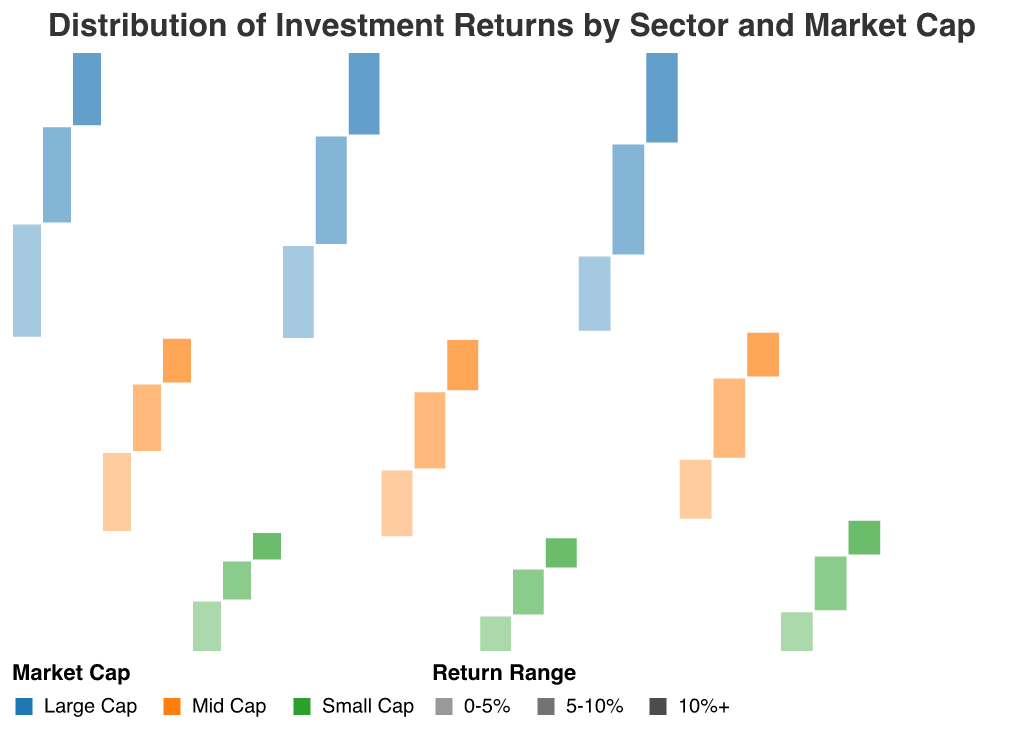What is the most common return range for large-cap technology investments? The mosaic plot shows different return ranges represented by varied opacities. For large-cap technology investments, the return range with the highest count will have the largest segment. The return range "5-10%" appears to have the most substantial section among large-cap technology.
Answer: 5-10% Which sector has the highest count of mid-cap investments with a return range of 10%+? In the mosaic plot, the section for mid-cap investments with a return range of 10%+ will be the darkest due to higher opacity. By comparing the sizes of each sector's mid-cap sections, Healthcare has the largest segment for this specific range.
Answer: Healthcare What is the combined count of small-cap investments in the financial and healthcare sectors? To get this, we add the counts of small-cap investments across the return ranges for both sectors. Financial has counts of 9 (0-5%), 7 (5-10%), and 5 (10%+). Healthcare has counts of 7 (0-5%), 9 (5-10%), and 6 (10%+). By summing these, we get 9 + 7 + 5 + 7 + 9 + 6 = 43.
Answer: 43 Is the proportion of 10%+ return investments larger in Technology or Financial sectors? By observing the mosaic plot, we compare the relative area of the 10%+ return sections (with the highest opacity) for both sectors. For the Technology sector, the 10%+ sections appear larger compared to those in the Financial sector.
Answer: Technology What's the overall count of investments in the sector with the highest mid-cap 0-5% return range? We first determine the sector with the largest mid-cap 0-5% portion by comparing segment sizes; for mid-cap 0-5%, the largest segment is in the Financial sector. Summing up all counts in Financial: 20+17+13+14+12+8+9+7+5 = 105.
Answer: 105 